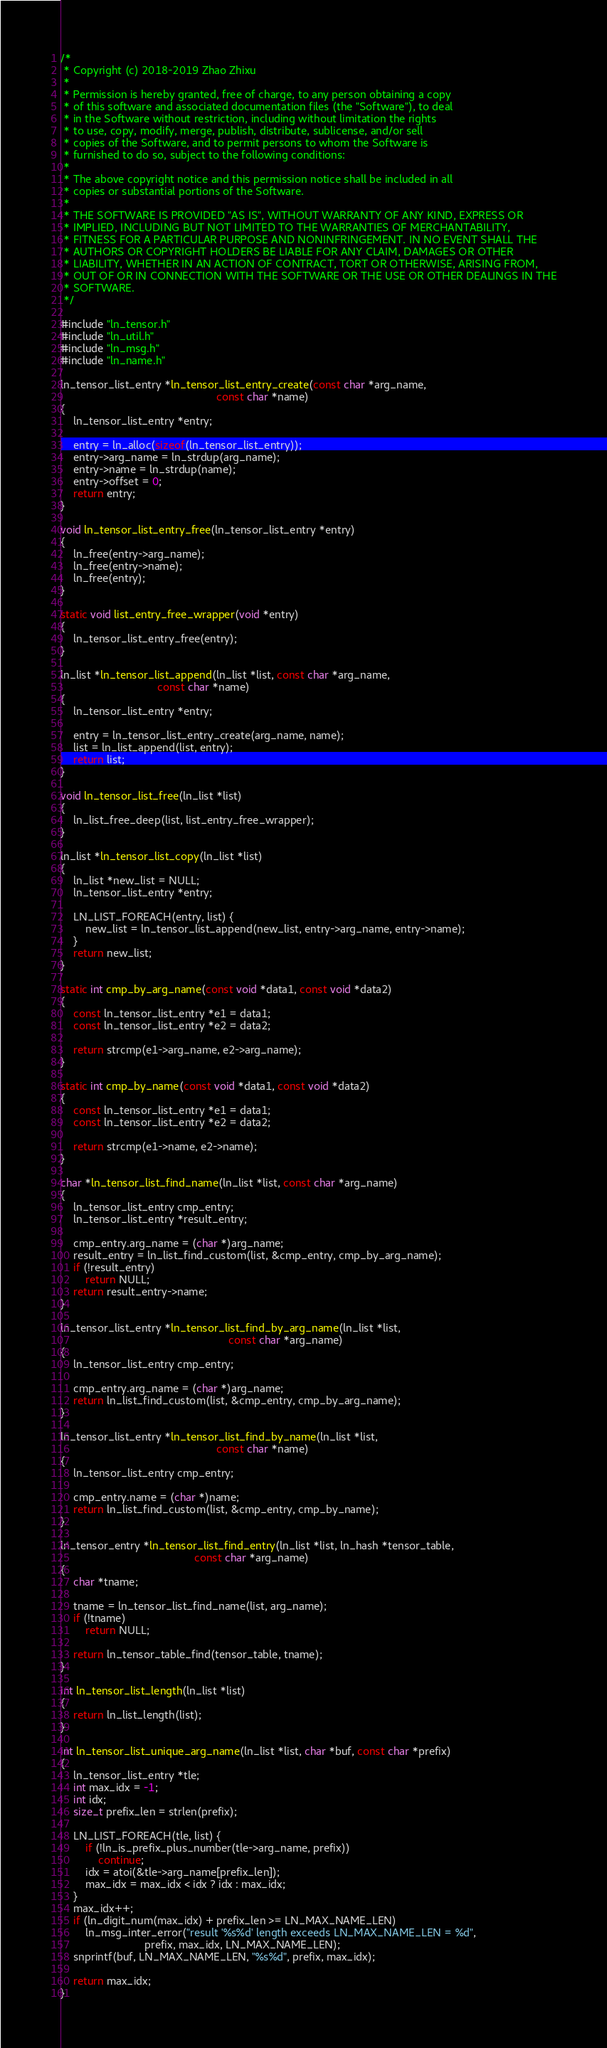<code> <loc_0><loc_0><loc_500><loc_500><_C_>/*
 * Copyright (c) 2018-2019 Zhao Zhixu
 *
 * Permission is hereby granted, free of charge, to any person obtaining a copy
 * of this software and associated documentation files (the "Software"), to deal
 * in the Software without restriction, including without limitation the rights
 * to use, copy, modify, merge, publish, distribute, sublicense, and/or sell
 * copies of the Software, and to permit persons to whom the Software is
 * furnished to do so, subject to the following conditions:
 *
 * The above copyright notice and this permission notice shall be included in all
 * copies or substantial portions of the Software.
 *
 * THE SOFTWARE IS PROVIDED "AS IS", WITHOUT WARRANTY OF ANY KIND, EXPRESS OR
 * IMPLIED, INCLUDING BUT NOT LIMITED TO THE WARRANTIES OF MERCHANTABILITY,
 * FITNESS FOR A PARTICULAR PURPOSE AND NONINFRINGEMENT. IN NO EVENT SHALL THE
 * AUTHORS OR COPYRIGHT HOLDERS BE LIABLE FOR ANY CLAIM, DAMAGES OR OTHER
 * LIABILITY, WHETHER IN AN ACTION OF CONTRACT, TORT OR OTHERWISE, ARISING FROM,
 * OUT OF OR IN CONNECTION WITH THE SOFTWARE OR THE USE OR OTHER DEALINGS IN THE
 * SOFTWARE.
 */

#include "ln_tensor.h"
#include "ln_util.h"
#include "ln_msg.h"
#include "ln_name.h"

ln_tensor_list_entry *ln_tensor_list_entry_create(const char *arg_name,
                                                  const char *name)
{
    ln_tensor_list_entry *entry;

    entry = ln_alloc(sizeof(ln_tensor_list_entry));
    entry->arg_name = ln_strdup(arg_name);
    entry->name = ln_strdup(name);
    entry->offset = 0;
    return entry;
}

void ln_tensor_list_entry_free(ln_tensor_list_entry *entry)
{
    ln_free(entry->arg_name);
    ln_free(entry->name);
    ln_free(entry);
}

static void list_entry_free_wrapper(void *entry)
{
    ln_tensor_list_entry_free(entry);
}

ln_list *ln_tensor_list_append(ln_list *list, const char *arg_name,
                               const char *name)
{
    ln_tensor_list_entry *entry;

    entry = ln_tensor_list_entry_create(arg_name, name);
    list = ln_list_append(list, entry);
    return list;
}

void ln_tensor_list_free(ln_list *list)
{
    ln_list_free_deep(list, list_entry_free_wrapper);
}

ln_list *ln_tensor_list_copy(ln_list *list)
{
    ln_list *new_list = NULL;
    ln_tensor_list_entry *entry;

    LN_LIST_FOREACH(entry, list) {
        new_list = ln_tensor_list_append(new_list, entry->arg_name, entry->name);
    }
    return new_list;
}

static int cmp_by_arg_name(const void *data1, const void *data2)
{
    const ln_tensor_list_entry *e1 = data1;
    const ln_tensor_list_entry *e2 = data2;

    return strcmp(e1->arg_name, e2->arg_name);
}

static int cmp_by_name(const void *data1, const void *data2)
{
    const ln_tensor_list_entry *e1 = data1;
    const ln_tensor_list_entry *e2 = data2;

    return strcmp(e1->name, e2->name);
}

char *ln_tensor_list_find_name(ln_list *list, const char *arg_name)
{
    ln_tensor_list_entry cmp_entry;
    ln_tensor_list_entry *result_entry;

    cmp_entry.arg_name = (char *)arg_name;
    result_entry = ln_list_find_custom(list, &cmp_entry, cmp_by_arg_name);
    if (!result_entry)
        return NULL;
    return result_entry->name;
}

ln_tensor_list_entry *ln_tensor_list_find_by_arg_name(ln_list *list,
                                                      const char *arg_name)
{
    ln_tensor_list_entry cmp_entry;

    cmp_entry.arg_name = (char *)arg_name;
    return ln_list_find_custom(list, &cmp_entry, cmp_by_arg_name);
}

ln_tensor_list_entry *ln_tensor_list_find_by_name(ln_list *list,
                                                  const char *name)
{
    ln_tensor_list_entry cmp_entry;

    cmp_entry.name = (char *)name;
    return ln_list_find_custom(list, &cmp_entry, cmp_by_name);
}

ln_tensor_entry *ln_tensor_list_find_entry(ln_list *list, ln_hash *tensor_table,
                                           const char *arg_name)
{
    char *tname;

    tname = ln_tensor_list_find_name(list, arg_name);
    if (!tname)
        return NULL;

    return ln_tensor_table_find(tensor_table, tname);
}

int ln_tensor_list_length(ln_list *list)
{
    return ln_list_length(list);
}

int ln_tensor_list_unique_arg_name(ln_list *list, char *buf, const char *prefix)
{
    ln_tensor_list_entry *tle;
    int max_idx = -1;
    int idx;
    size_t prefix_len = strlen(prefix);

    LN_LIST_FOREACH(tle, list) {
        if (!ln_is_prefix_plus_number(tle->arg_name, prefix))
            continue;
        idx = atoi(&tle->arg_name[prefix_len]);
        max_idx = max_idx < idx ? idx : max_idx;
    }
    max_idx++;
    if (ln_digit_num(max_idx) + prefix_len >= LN_MAX_NAME_LEN)
        ln_msg_inter_error("result '%s%d' length exceeds LN_MAX_NAME_LEN = %d",
                           prefix, max_idx, LN_MAX_NAME_LEN);
    snprintf(buf, LN_MAX_NAME_LEN, "%s%d", prefix, max_idx);

    return max_idx;
}
</code> 